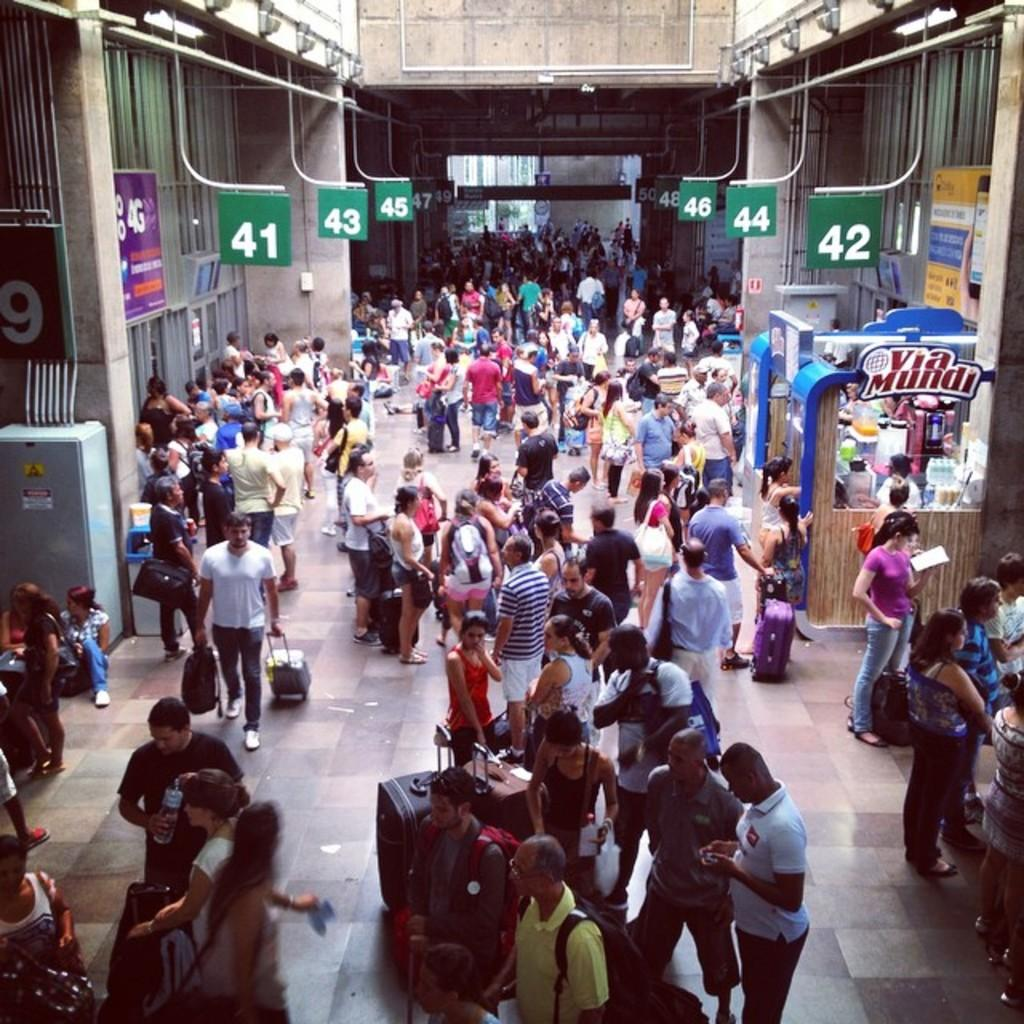What are the people in the image doing? The people in the image are on a path. What can be seen in the image besides the people? There is a stall, a box, pipes, boards, banners, and walls in the image. What might the people be carrying with them? The people holding luggage in the image are carrying their belongings. What type of metal chair can be seen in the image? There is no metal chair present in the image. What type of flag is being waved by the people in the image? There are no flags or people waving flags in the image. 